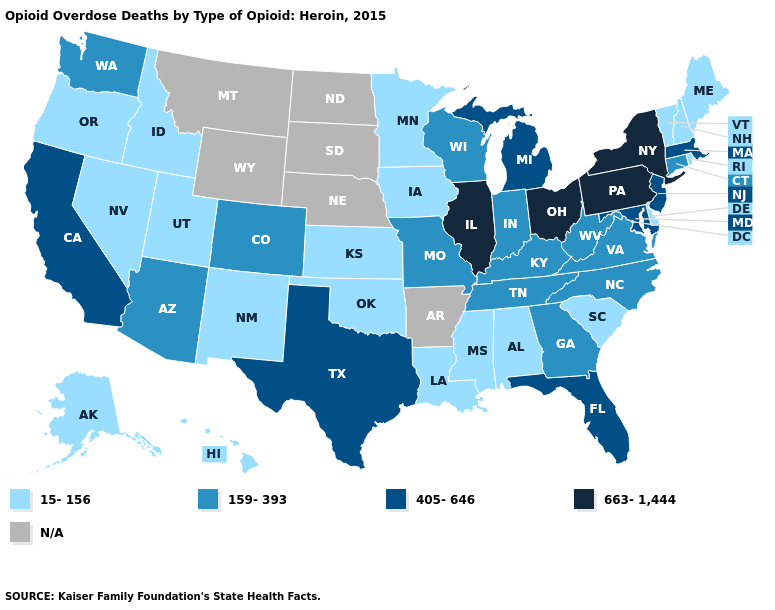What is the value of Utah?
Answer briefly. 15-156. Does Vermont have the highest value in the USA?
Concise answer only. No. Does the map have missing data?
Write a very short answer. Yes. Name the states that have a value in the range 405-646?
Answer briefly. California, Florida, Maryland, Massachusetts, Michigan, New Jersey, Texas. What is the value of Maryland?
Keep it brief. 405-646. Does the map have missing data?
Write a very short answer. Yes. Does Indiana have the lowest value in the MidWest?
Give a very brief answer. No. Which states have the highest value in the USA?
Short answer required. Illinois, New York, Ohio, Pennsylvania. What is the value of Illinois?
Give a very brief answer. 663-1,444. Among the states that border Georgia , does Florida have the highest value?
Keep it brief. Yes. Name the states that have a value in the range N/A?
Short answer required. Arkansas, Montana, Nebraska, North Dakota, South Dakota, Wyoming. What is the value of Illinois?
Concise answer only. 663-1,444. What is the value of Pennsylvania?
Short answer required. 663-1,444. Which states have the lowest value in the USA?
Give a very brief answer. Alabama, Alaska, Delaware, Hawaii, Idaho, Iowa, Kansas, Louisiana, Maine, Minnesota, Mississippi, Nevada, New Hampshire, New Mexico, Oklahoma, Oregon, Rhode Island, South Carolina, Utah, Vermont. Name the states that have a value in the range 15-156?
Give a very brief answer. Alabama, Alaska, Delaware, Hawaii, Idaho, Iowa, Kansas, Louisiana, Maine, Minnesota, Mississippi, Nevada, New Hampshire, New Mexico, Oklahoma, Oregon, Rhode Island, South Carolina, Utah, Vermont. 